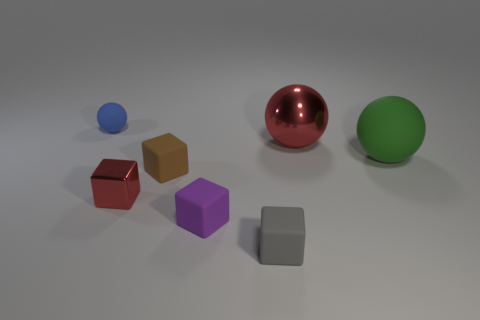Is the large metallic object the same color as the metal block?
Your response must be concise. Yes. What number of red metal things are behind the rubber ball that is in front of the tiny blue matte ball?
Offer a terse response. 1. There is a shiny block that is in front of the matte sphere in front of the tiny matte thing that is on the left side of the small red metal cube; how big is it?
Provide a succinct answer. Small. Is the color of the metallic thing behind the tiny red shiny object the same as the tiny metal cube?
Give a very brief answer. Yes. There is another rubber thing that is the same shape as the big green thing; what size is it?
Give a very brief answer. Small. How many objects are either rubber spheres that are right of the brown matte block or small objects that are left of the tiny brown matte cube?
Offer a very short reply. 3. There is a large thing behind the rubber thing that is right of the gray matte block; what is its shape?
Provide a short and direct response. Sphere. Are there any other things that are the same color as the big matte thing?
Your response must be concise. No. What number of things are green matte objects or rubber cubes?
Ensure brevity in your answer.  4. Is there a matte object that has the same size as the metal sphere?
Make the answer very short. Yes. 